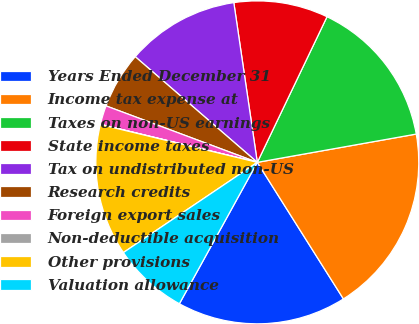<chart> <loc_0><loc_0><loc_500><loc_500><pie_chart><fcel>Years Ended December 31<fcel>Income tax expense at<fcel>Taxes on non-US earnings<fcel>State income taxes<fcel>Tax on undistributed non-US<fcel>Research credits<fcel>Foreign export sales<fcel>Non-deductible acquisition<fcel>Other provisions<fcel>Valuation allowance<nl><fcel>16.97%<fcel>18.85%<fcel>15.09%<fcel>9.43%<fcel>11.32%<fcel>5.67%<fcel>1.9%<fcel>0.02%<fcel>13.2%<fcel>7.55%<nl></chart> 